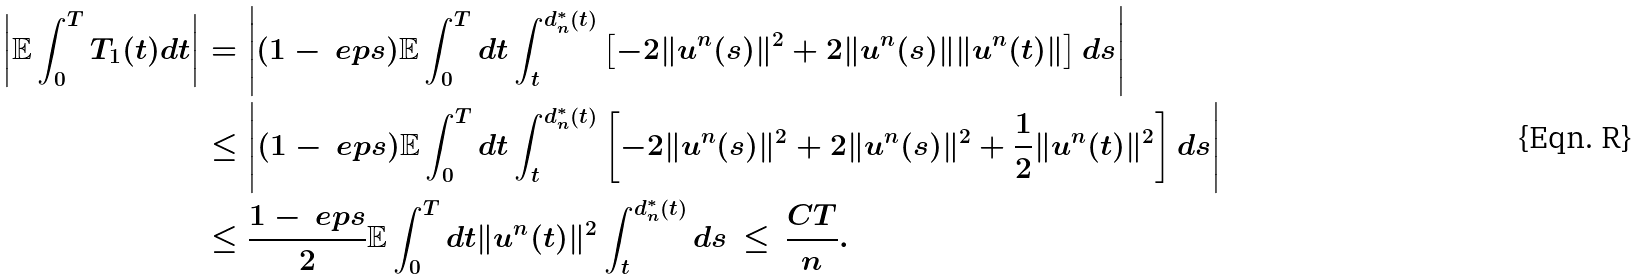<formula> <loc_0><loc_0><loc_500><loc_500>\left | \mathbb { E } \int _ { 0 } ^ { T } T _ { 1 } ( t ) d t \right | & = \left | ( 1 - \ e p s ) \mathbb { E } \int _ { 0 } ^ { T } d t \int _ { t } ^ { d _ { n } ^ { * } ( t ) } \left [ - 2 \| u ^ { n } ( s ) \| ^ { 2 } + 2 \| u ^ { n } ( s ) \| \| u ^ { n } ( t ) \| \right ] d s \right | \\ & \leq \left | ( 1 - \ e p s ) \mathbb { E } \int _ { 0 } ^ { T } d t \int _ { t } ^ { d _ { n } ^ { * } ( t ) } \left [ - 2 \| u ^ { n } ( s ) \| ^ { 2 } + 2 \| u ^ { n } ( s ) \| ^ { 2 } + \frac { 1 } { 2 } \| u ^ { n } ( t ) \| ^ { 2 } \right ] d s \right | \\ & \leq \frac { 1 - \ e p s } { 2 } \mathbb { E } \int _ { 0 } ^ { T } d t \| u ^ { n } ( t ) \| ^ { 2 } \int _ { t } ^ { d _ { n } ^ { * } ( t ) } d s \, \leq \, \frac { C T } { n } .</formula> 